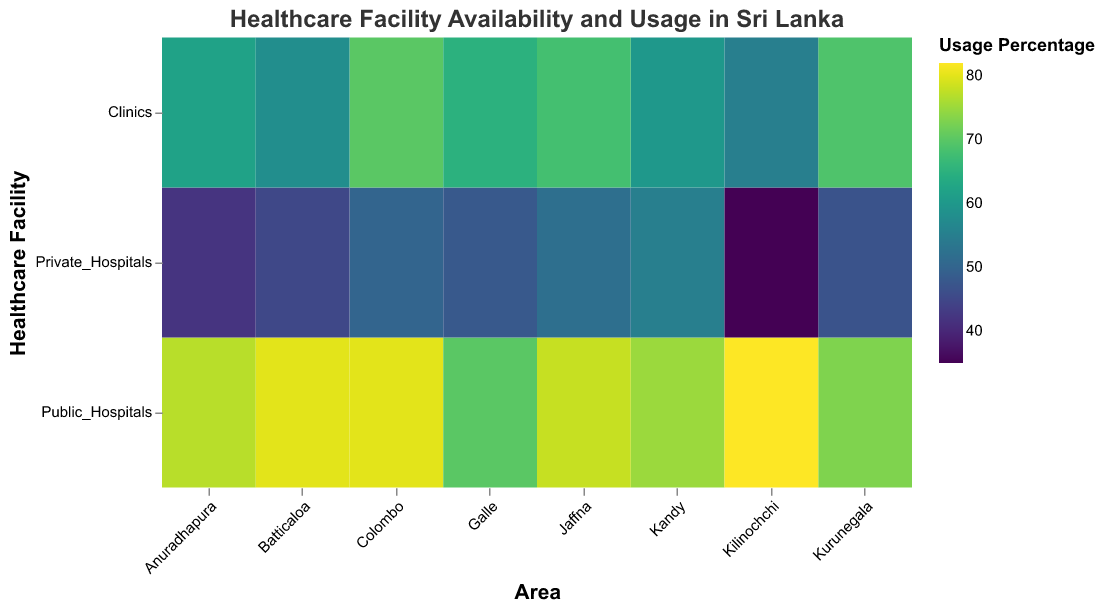Which area has the highest usage percentage for public hospitals? Look for the area with the darkest color in the row corresponding to "Public_Hospitals." Kilinochchi has the highest usage percentage at 82%.
Answer: Kilinochchi What is the average waiting time in clinics across Colombo, Kandy, and Galle? Identify the waiting times for clinics in Colombo (15), Kandy (12), and Galle (10). Sum these values and divide by 3: (15+12+10)/3 = 37/3 ≈ 12.33.
Answer: 12.33 minutes Which type of healthcare facility has the highest average usage rate across all areas? Calculate the average usage rate for each type of facility. The average for public hospitals: (80 + 75 + 70 + 78 + 73 + 82 + 77 + 80) / 8 = 78.125. The average for private hospitals: (50 + 55 + 48 + 52 + 47 + 35 + 42 + 45) / 8 = 46.75. The average for clinics: (70 + 60 + 65 + 68 + 69 + 55 + 62 + 58) / 8 = 63.375. Public hospitals have the highest average usage rate.
Answer: Public hospitals How does the number of clinics compare between Colombo and Kurunegala? Compare the number of clinics in Colombo (20) with that in Kurunegala (13). Colombo has 7 more clinics than Kurunegala.
Answer: Colombo has 7 more clinics What is the total number of public hospitals in all areas combined? Sum the numbers of public hospitals across all areas: 15 + 10 + 8 + 7 + 9 + 3 + 5 + 4 = 61.
Answer: 61 Which area has the lowest average waiting time in clinics, and what is the time? Look for the lowest waiting time value in the row corresponding to "Clinics." Galle has the lowest average waiting time of 10 minutes.
Answer: Galle, 10 minutes What percentage of the population is served by private hospitals in Kandy? Locate the value under "Population_Covered" for "Private_Hospitals" in Kandy, which is 120,000. Then refer to the population covered details for private hospitals in Kandy specifically.
Answer: 120,000 people Which healthcare facility in Jaffna has the highest usage percentage? Look for the highest color intensity in the Jaffna column. Public hospitals in Jaffna have the highest usage percentage at 78%.
Answer: Public hospitals Between Kilinochchi and Anuradhapura, which one has a higher population coverage for clinics? Compare the population coverage of clinics: Kilinochchi (60,000) and Anuradhapura (95,000). Anuradhapura covers more population with 95,000.
Answer: Anuradhapura What is the average population covered by private hospitals across all areas? Calculate the total population covered by private hospitals and divide it by the number of areas. The total population is 150,000 + 120,000 + 110,000 + 100,000 + 100,000 + 40,000 + 60,000 + 55,000 = 735,000. The average is 735,000 / 8 = 91,875.
Answer: 91,875 people 